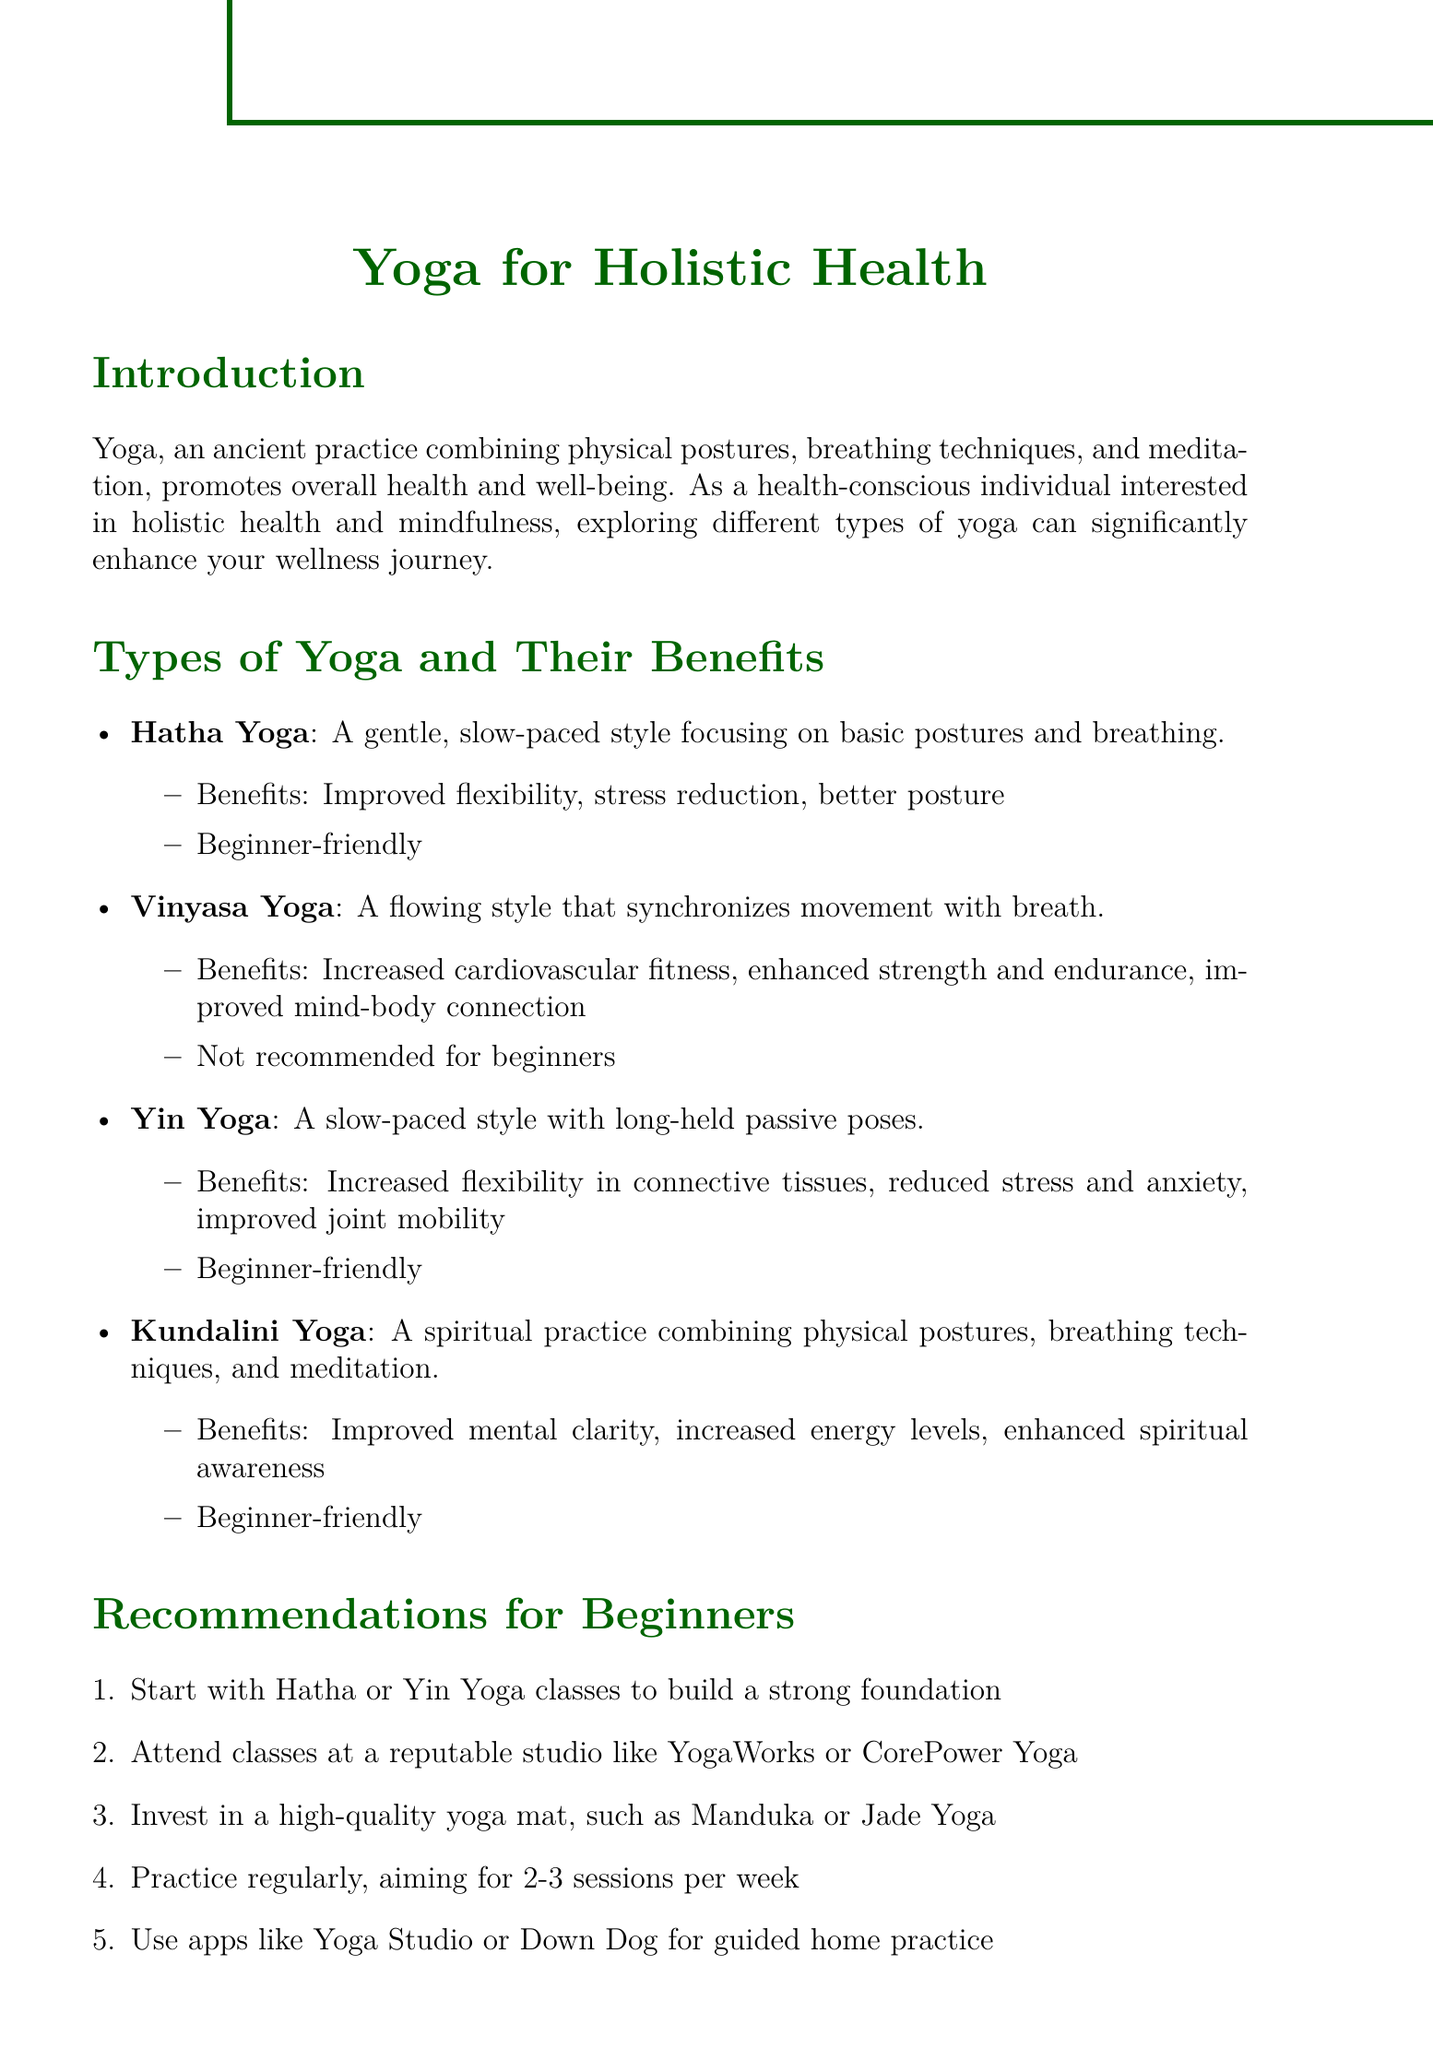What is the definition of Hatha Yoga? Hatha Yoga is defined in the document as a gentle, slow-paced style focusing on basic postures and breathing.
Answer: A gentle, slow-paced style focusing on basic postures and breathing What are the benefits of Yin Yoga? The document lists the benefits of Yin Yoga, which include increased flexibility in connective tissues, reduced stress and anxiety, and improved joint mobility.
Answer: Increased flexibility in connective tissues, reduced stress and anxiety, improved joint mobility Which type of yoga is recommended for beginners? The document explicitly mentions Hatha and Yin Yoga as beginner-friendly practices.
Answer: Hatha or Yin Yoga What is the recommended frequency of yoga practice for beginners? The memo suggests that beginners should practice regularly, aiming for 2-3 sessions per week.
Answer: 2-3 sessions per week What complementary practice is suggested alongside yoga? The document lists meditation, Ayurveda, and Pranayama as complementary practices that support holistic health.
Answer: Meditation What is the source of the findings regarding yoga's effects on anxiety and depression? The document cites the Harvard Mental Health Letter as the source of findings related to yoga's benefits for anxiety and depression.
Answer: Harvard Mental Health Letter Which yoga style enhances cardiovascular fitness? Vinyasa Yoga is mentioned in the document as a style that enhances cardiovascular fitness.
Answer: Vinyasa Yoga What should beginners invest in according to the recommendations? The document advises beginners to invest in a high-quality yoga mat.
Answer: A high-quality yoga mat 